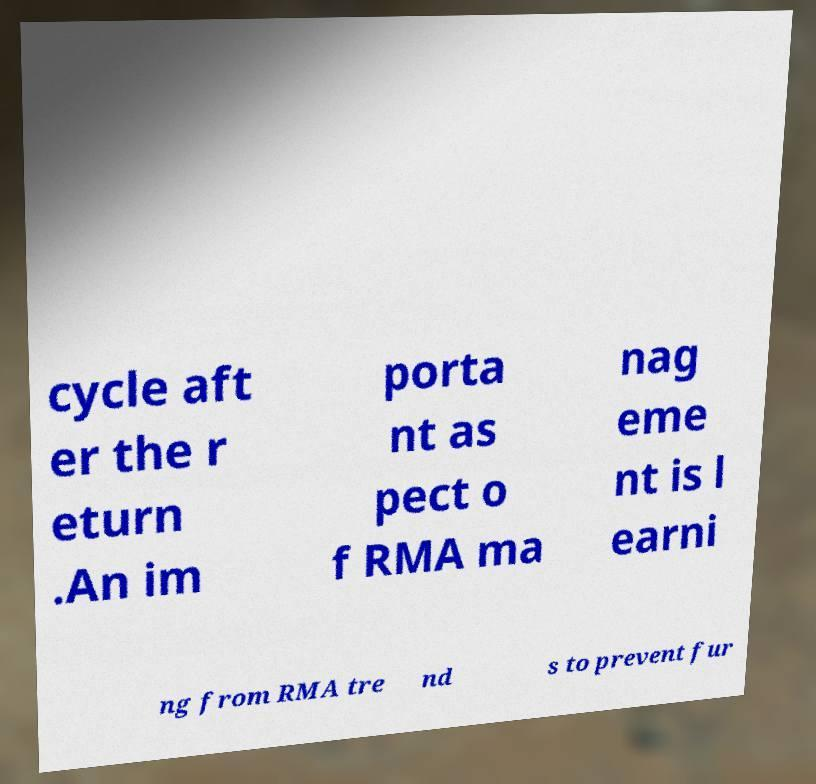For documentation purposes, I need the text within this image transcribed. Could you provide that? cycle aft er the r eturn .An im porta nt as pect o f RMA ma nag eme nt is l earni ng from RMA tre nd s to prevent fur 